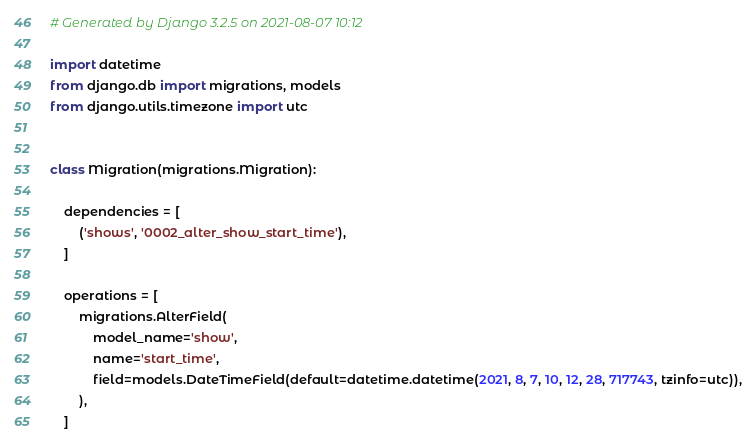Convert code to text. <code><loc_0><loc_0><loc_500><loc_500><_Python_># Generated by Django 3.2.5 on 2021-08-07 10:12

import datetime
from django.db import migrations, models
from django.utils.timezone import utc


class Migration(migrations.Migration):

    dependencies = [
        ('shows', '0002_alter_show_start_time'),
    ]

    operations = [
        migrations.AlterField(
            model_name='show',
            name='start_time',
            field=models.DateTimeField(default=datetime.datetime(2021, 8, 7, 10, 12, 28, 717743, tzinfo=utc)),
        ),
    ]
</code> 